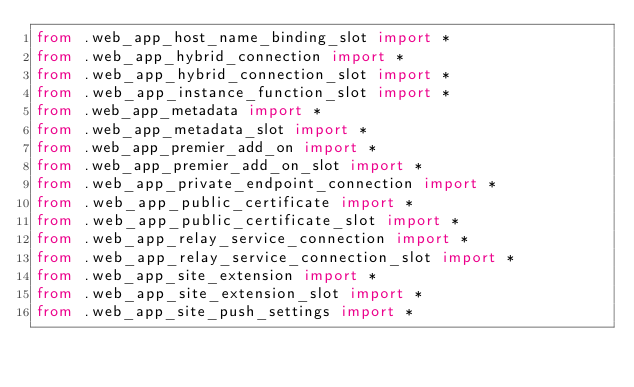<code> <loc_0><loc_0><loc_500><loc_500><_Python_>from .web_app_host_name_binding_slot import *
from .web_app_hybrid_connection import *
from .web_app_hybrid_connection_slot import *
from .web_app_instance_function_slot import *
from .web_app_metadata import *
from .web_app_metadata_slot import *
from .web_app_premier_add_on import *
from .web_app_premier_add_on_slot import *
from .web_app_private_endpoint_connection import *
from .web_app_public_certificate import *
from .web_app_public_certificate_slot import *
from .web_app_relay_service_connection import *
from .web_app_relay_service_connection_slot import *
from .web_app_site_extension import *
from .web_app_site_extension_slot import *
from .web_app_site_push_settings import *</code> 